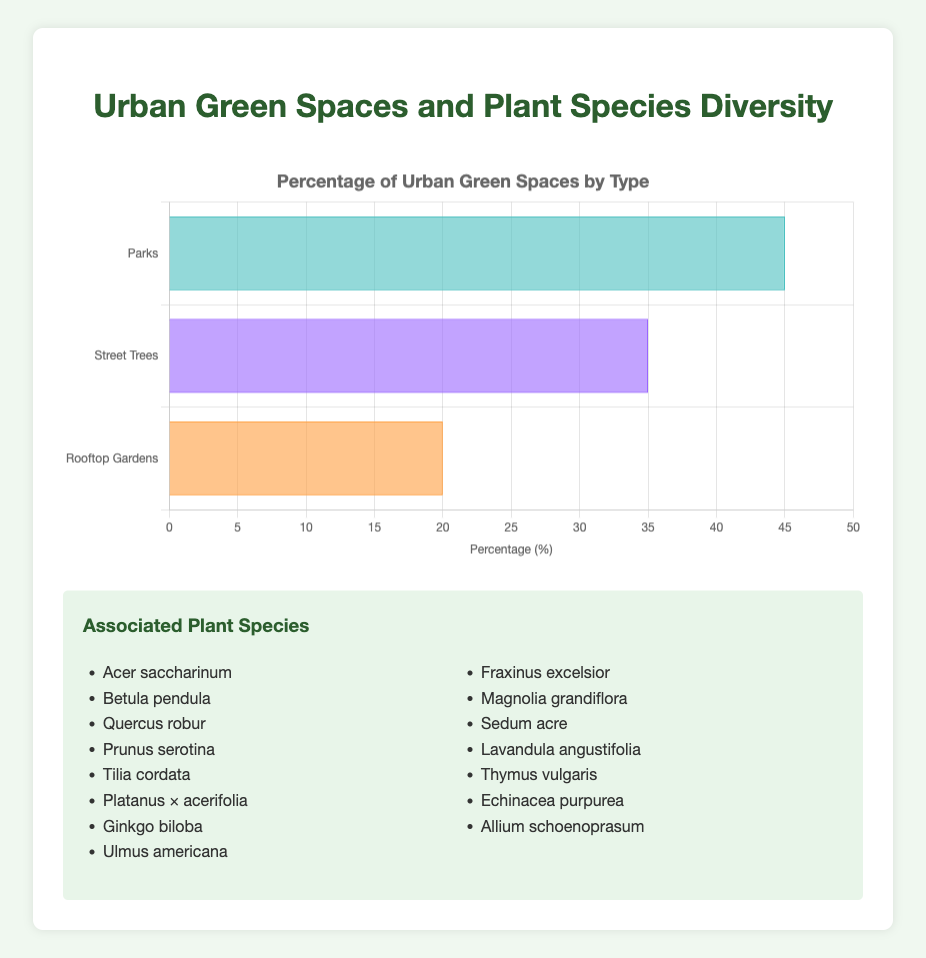Which type of urban green space has the highest percentage? Observing the horizontal bar chart, the largest bar corresponds to Parks, which occupy 45% of urban green spaces.
Answer: Parks How much more percentage of urban green spaces do Parks cover compared to Rooftop Gardens? To find the difference, subtract the percentage of Rooftop Gardens (20%) from the percentage of Parks (45%): 45% - 20% = 25%.
Answer: 25% What is the total percentage of urban green spaces covered by Parks and Street Trees together? Add the percentages of Parks (45%) and Street Trees (35%): 45% + 35% = 80%.
Answer: 80% Which urban green space type has the lowest associated plant species diversity? Compare the number of species listed for each type: Parks and Street Trees each have 5 species, while Rooftop Gardens also have 5 species. Therefore, all types have equal associated plant species diversity.
Answer: All types have equal diversity If the total area of urban green space is 1000 hectares, how many hectares are covered by Street Trees? Multiply the percentage of Street Trees (35%) by the total area (1000 hectares): (35/100) * 1000 = 350 hectares.
Answer: 350 hectares Which urban green space type has the shortest bar? Observing the horizontal bar chart, the shortest bar corresponds to Rooftop Gardens, which cover 20% of urban green spaces.
Answer: Rooftop Gardens What color represents Street Trees in the bar chart? The color of the second bar in the horizontal bar chart, which represents Street Trees, is purple.
Answer: Purple If we add 5% more rooftop gardens to the urban green spaces, what will be the new percentage for rooftop gardens? Add 5% to the current percentage of rooftop gardens (20%): 20% + 5% = 25%.
Answer: 25% Which urban green space has more associated plant species diversity, Parks or Street Trees? Both Parks and Street Trees have the same number of associated plant species, which is 5 species each.
Answer: Same If we were to evenly distribute the existing percentage of Parks among Street Trees and Rooftop Gardens, what would be the new percentage for Street Trees and Rooftop Gardens? Distribute the parks' percentage (45%) evenly between Street Trees and Rooftop Gardens, which means adding half of 45% to each: 45%/2 = 22.5%. So, Street Trees new percentage: 35% + 22.5% = 57.5%, and Rooftop Gardens new percentage: 20% + 22.5% = 42.5%.
Answer: Street Trees: 57.5%, Rooftop Gardens: 42.5% 